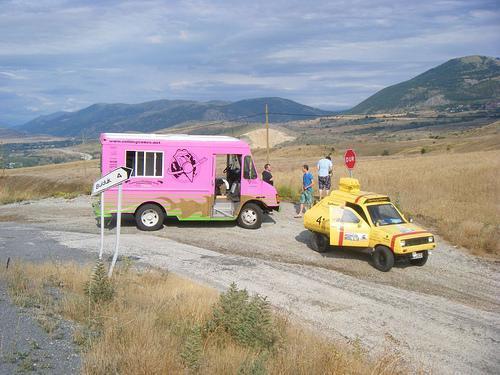How many people are there?
Give a very brief answer. 3. How many vehicles are there?
Give a very brief answer. 2. How many trucks are visible?
Give a very brief answer. 2. How many tents in this image are to the left of the rainbow-colored umbrella at the end of the wooden walkway?
Give a very brief answer. 0. 